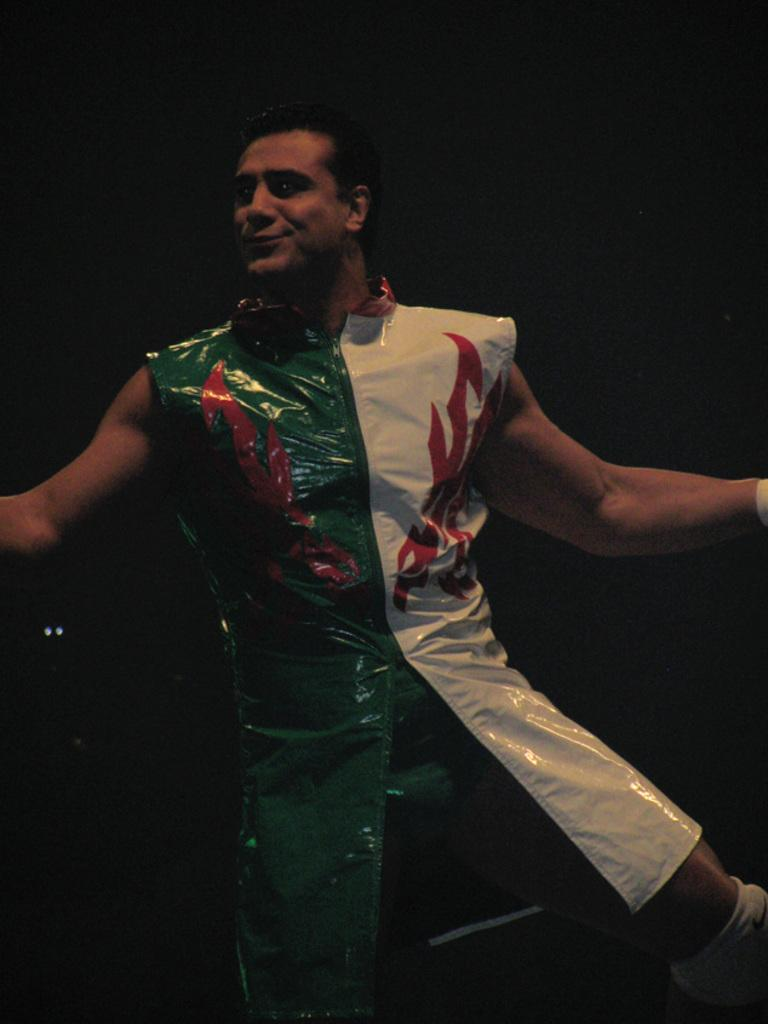What is the main subject of the image? The main subject of the image is a man. What is the man wearing in the image? The man is wearing costumes in the image. Can you describe the background of the image? The background of the image is dark. What type of metal can be seen in the man's stomach in the image? There is no metal visible in the man's stomach in the image. What type of trousers is the man wearing in the image? The provided facts do not mention the type of trousers the man is wearing in the image. 